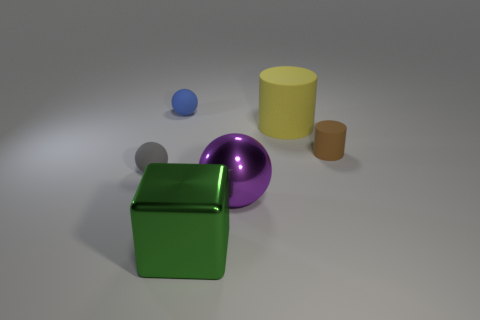Subtract all small balls. How many balls are left? 1 Add 1 blue matte cylinders. How many objects exist? 7 Subtract all blocks. How many objects are left? 5 Subtract 0 red spheres. How many objects are left? 6 Subtract all large yellow balls. Subtract all blue objects. How many objects are left? 5 Add 2 purple shiny things. How many purple shiny things are left? 3 Add 1 large yellow objects. How many large yellow objects exist? 2 